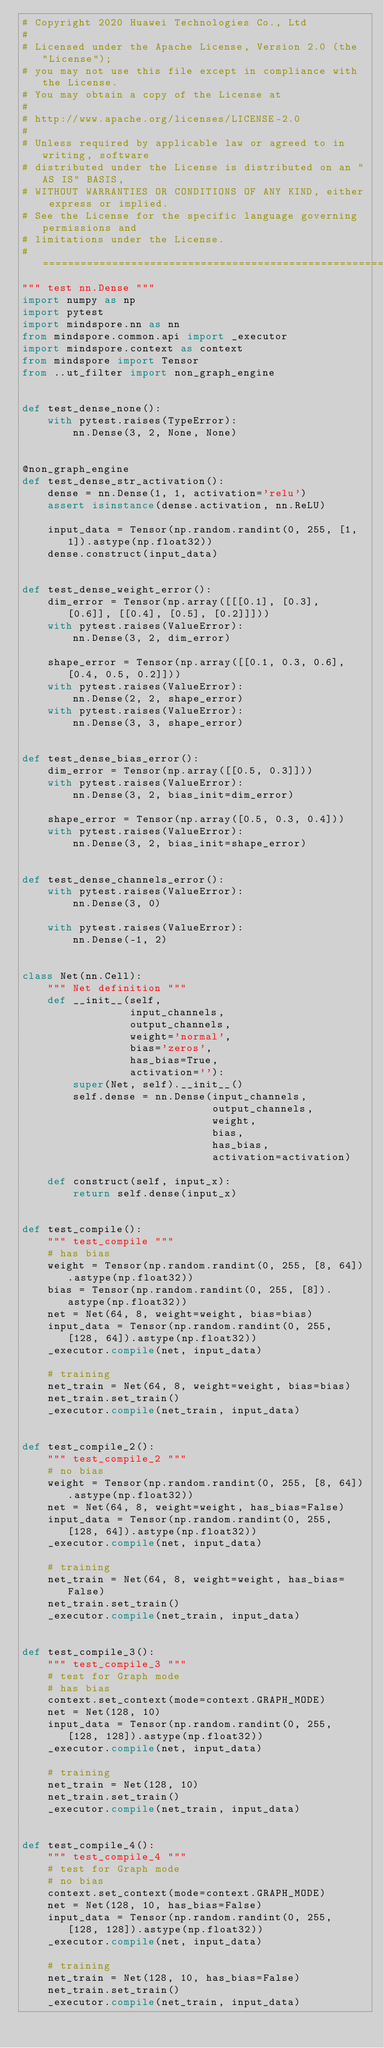<code> <loc_0><loc_0><loc_500><loc_500><_Python_># Copyright 2020 Huawei Technologies Co., Ltd
#
# Licensed under the Apache License, Version 2.0 (the "License");
# you may not use this file except in compliance with the License.
# You may obtain a copy of the License at
#
# http://www.apache.org/licenses/LICENSE-2.0
#
# Unless required by applicable law or agreed to in writing, software
# distributed under the License is distributed on an "AS IS" BASIS,
# WITHOUT WARRANTIES OR CONDITIONS OF ANY KIND, either express or implied.
# See the License for the specific language governing permissions and
# limitations under the License.
# ============================================================================
""" test nn.Dense """
import numpy as np
import pytest
import mindspore.nn as nn
from mindspore.common.api import _executor
import mindspore.context as context
from mindspore import Tensor
from ..ut_filter import non_graph_engine


def test_dense_none():
    with pytest.raises(TypeError):
        nn.Dense(3, 2, None, None)


@non_graph_engine
def test_dense_str_activation():
    dense = nn.Dense(1, 1, activation='relu')
    assert isinstance(dense.activation, nn.ReLU)

    input_data = Tensor(np.random.randint(0, 255, [1, 1]).astype(np.float32))
    dense.construct(input_data)


def test_dense_weight_error():
    dim_error = Tensor(np.array([[[0.1], [0.3], [0.6]], [[0.4], [0.5], [0.2]]]))
    with pytest.raises(ValueError):
        nn.Dense(3, 2, dim_error)

    shape_error = Tensor(np.array([[0.1, 0.3, 0.6], [0.4, 0.5, 0.2]]))
    with pytest.raises(ValueError):
        nn.Dense(2, 2, shape_error)
    with pytest.raises(ValueError):
        nn.Dense(3, 3, shape_error)


def test_dense_bias_error():
    dim_error = Tensor(np.array([[0.5, 0.3]]))
    with pytest.raises(ValueError):
        nn.Dense(3, 2, bias_init=dim_error)

    shape_error = Tensor(np.array([0.5, 0.3, 0.4]))
    with pytest.raises(ValueError):
        nn.Dense(3, 2, bias_init=shape_error)


def test_dense_channels_error():
    with pytest.raises(ValueError):
        nn.Dense(3, 0)

    with pytest.raises(ValueError):
        nn.Dense(-1, 2)


class Net(nn.Cell):
    """ Net definition """
    def __init__(self,
                 input_channels,
                 output_channels,
                 weight='normal',
                 bias='zeros',
                 has_bias=True,
                 activation=''):
        super(Net, self).__init__()
        self.dense = nn.Dense(input_channels,
                              output_channels,
                              weight,
                              bias,
                              has_bias,
                              activation=activation)

    def construct(self, input_x):
        return self.dense(input_x)


def test_compile():
    """ test_compile """
    # has bias
    weight = Tensor(np.random.randint(0, 255, [8, 64]).astype(np.float32))
    bias = Tensor(np.random.randint(0, 255, [8]).astype(np.float32))
    net = Net(64, 8, weight=weight, bias=bias)
    input_data = Tensor(np.random.randint(0, 255, [128, 64]).astype(np.float32))
    _executor.compile(net, input_data)

    # training
    net_train = Net(64, 8, weight=weight, bias=bias)
    net_train.set_train()
    _executor.compile(net_train, input_data)


def test_compile_2():
    """ test_compile_2 """
    # no bias
    weight = Tensor(np.random.randint(0, 255, [8, 64]).astype(np.float32))
    net = Net(64, 8, weight=weight, has_bias=False)
    input_data = Tensor(np.random.randint(0, 255, [128, 64]).astype(np.float32))
    _executor.compile(net, input_data)

    # training
    net_train = Net(64, 8, weight=weight, has_bias=False)
    net_train.set_train()
    _executor.compile(net_train, input_data)


def test_compile_3():
    """ test_compile_3 """
    # test for Graph mode
    # has bias
    context.set_context(mode=context.GRAPH_MODE)
    net = Net(128, 10)
    input_data = Tensor(np.random.randint(0, 255, [128, 128]).astype(np.float32))
    _executor.compile(net, input_data)

    # training
    net_train = Net(128, 10)
    net_train.set_train()
    _executor.compile(net_train, input_data)


def test_compile_4():
    """ test_compile_4 """
    # test for Graph mode
    # no bias
    context.set_context(mode=context.GRAPH_MODE)
    net = Net(128, 10, has_bias=False)
    input_data = Tensor(np.random.randint(0, 255, [128, 128]).astype(np.float32))
    _executor.compile(net, input_data)

    # training
    net_train = Net(128, 10, has_bias=False)
    net_train.set_train()
    _executor.compile(net_train, input_data)
</code> 